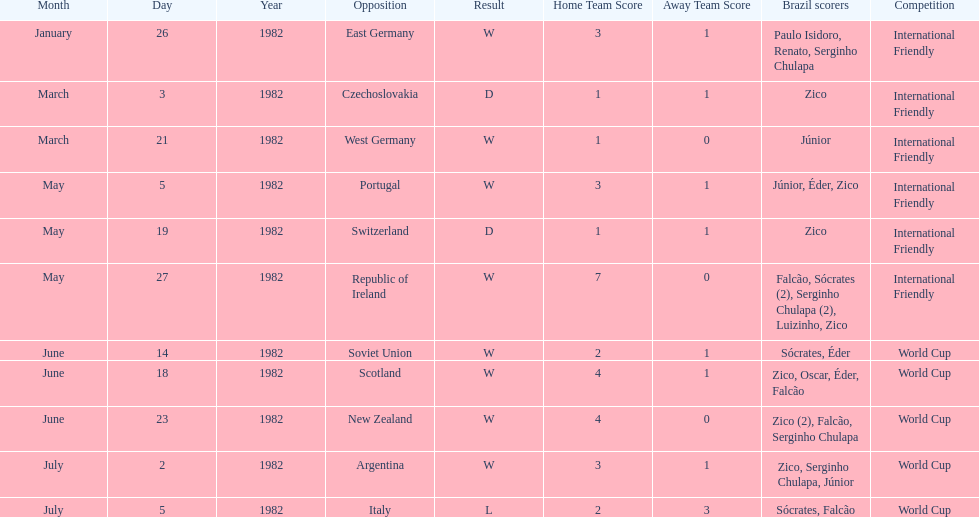How many games did zico end up scoring in during this season? 7. 